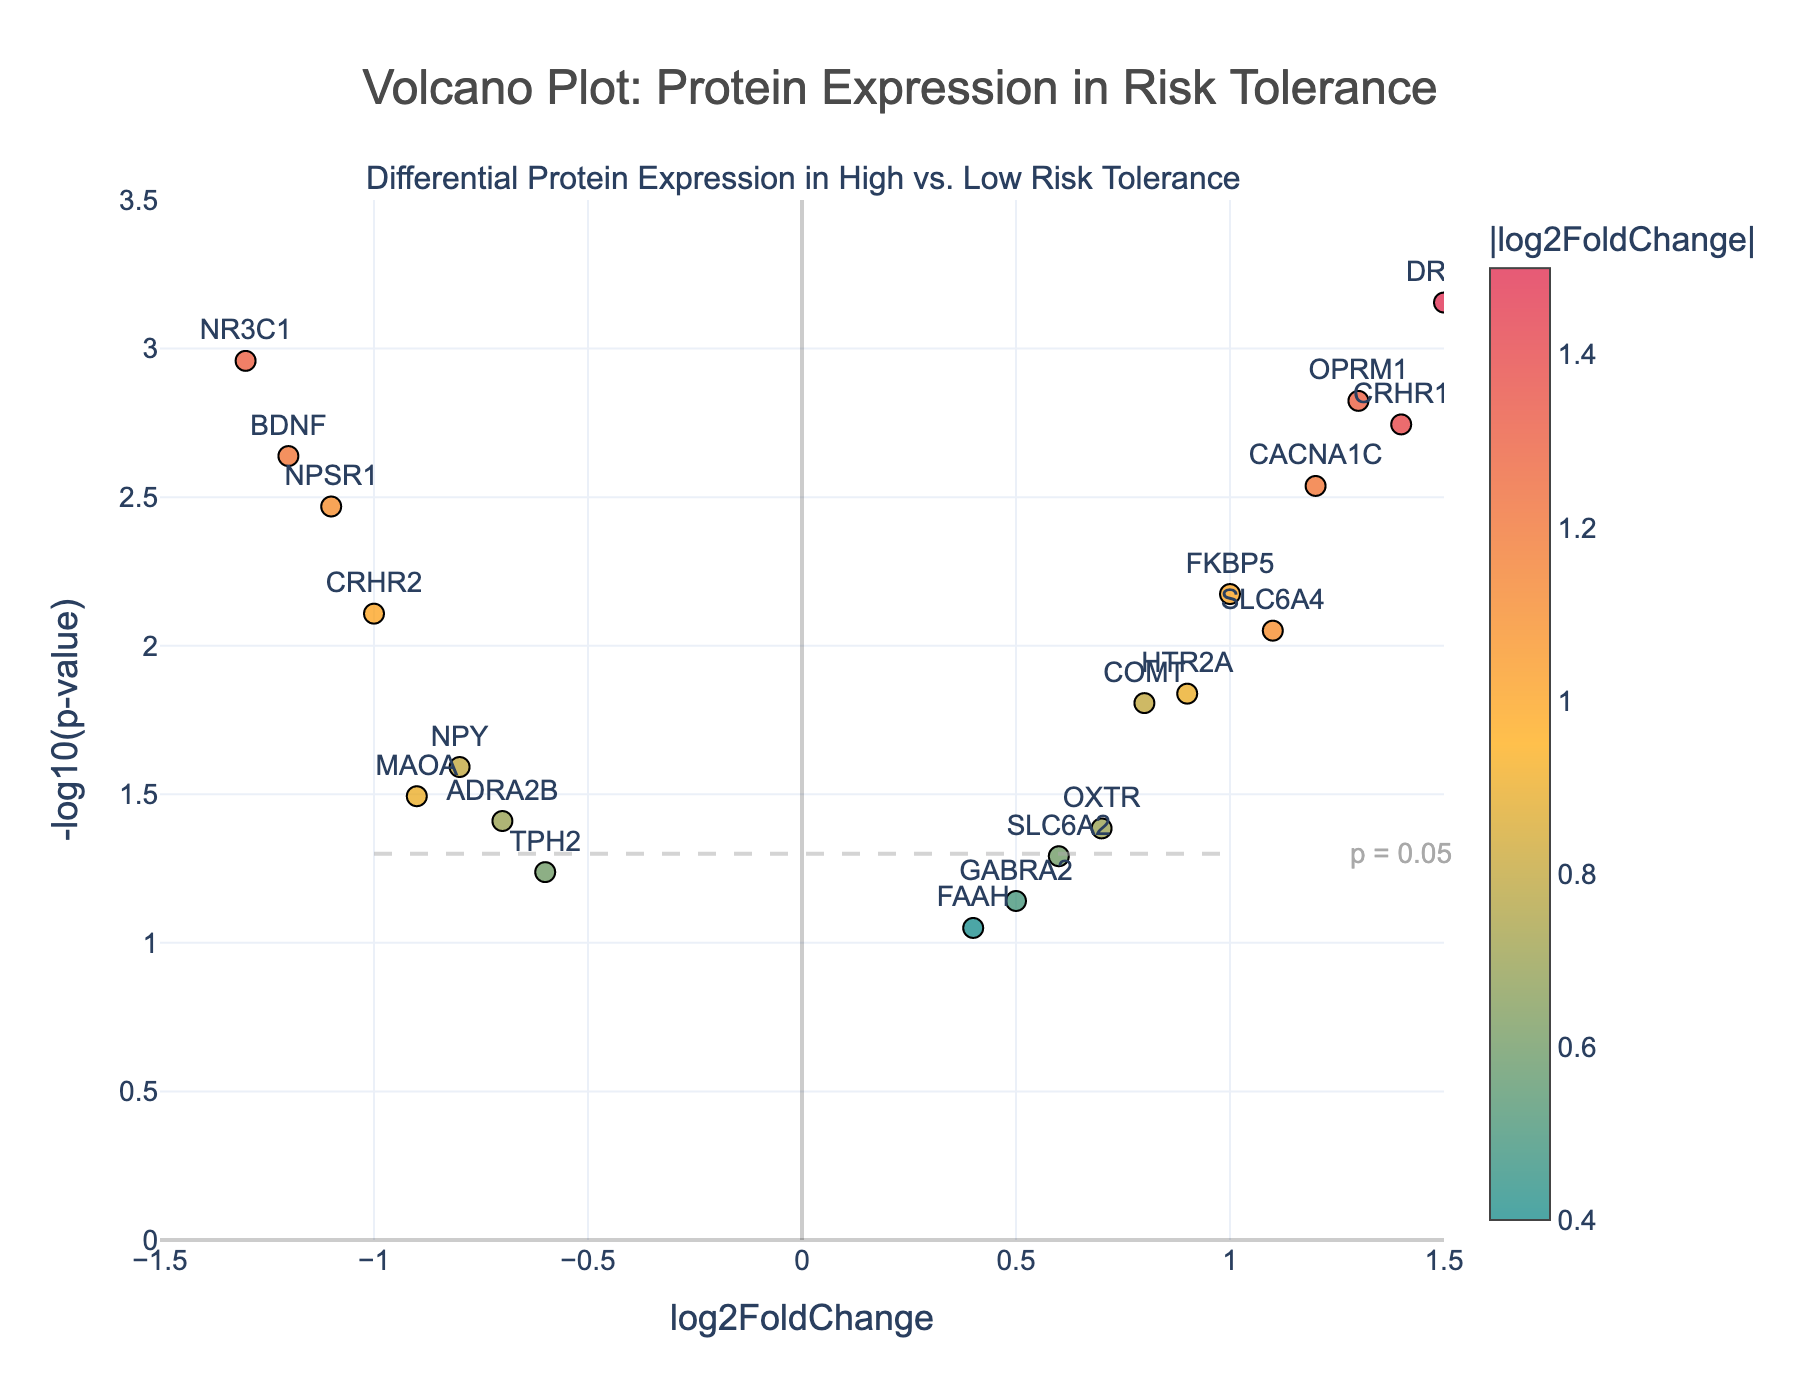How many proteins are plotted in the figure? Count all the protein points shown in the figure. There are 19 proteins listed in the data.
Answer: 19 What protein shows the highest positive log2FoldChange? Identify the protein with the highest positive x-axis value. DRD2 has the highest log2FoldChange value of 1.5.
Answer: DRD2 What protein has the smallest p-value? Look for the protein with the highest y-axis value, which represents the smallest p-value in the figure. DRD2 has the smallest p-value, with -log10(p-value) of approximately 3.15.
Answer: DRD2 Which protein has the most significant negative log2FoldChange? Identify the protein with the most negative x-axis value. NR3C1 has the most significant negative log2FoldChange value of -1.3.
Answer: NR3C1 How many proteins have a log2FoldChange greater than 1? Count proteins with log2FoldChange values greater than 1. There are five proteins: DRD2, CRHR1, SLC6A4, CACNA1C, and OPRM1.
Answer: 5 Which protein closest to the point where log2FoldChange is 0 and -log10(p-value) is 1.3? Find the protein point closest to the coordinates (0, 1.3). The suffix line p = 0.05 line crosses around -log10(p-value) = 1.3. Several proteins, including MAOA and OXTR, lie close, but OXTR is slightly closer.
Answer: OXTR Are there more proteins with significant overexpression or underexpression? Compare the number of proteins with positive log2FoldChange (overexpression) to those with negative log2FoldChange (underexpression). There are 10 positively expressed proteins and 9 negatively expressed proteins.
Answer: Overexpression Which two proteins have nearly identical log2FoldChange values but differ significantly in their p-values? Compare proteins' log2FoldChange values and p-values to find closely matching x-values but differing y-values. HTR2A and COMT have similar log2FoldChange (both around 0.8-0.9) but their p-values differ more significantly (-log10(p-value) around 2.8 for HTR2A and around 1.8 for COMT).
Answer: HTR2A and COMT What is the range of p-values plotted? Determine the minimum and maximum p-values corresponding to -log10(p-value) values plotted. With -log10(p-value) ranging from 0 to approximately 3.5, the p-value range is from 10^0 (1) to 10^-3.5 (~0.0003).
Answer: 1 to 0.0003 